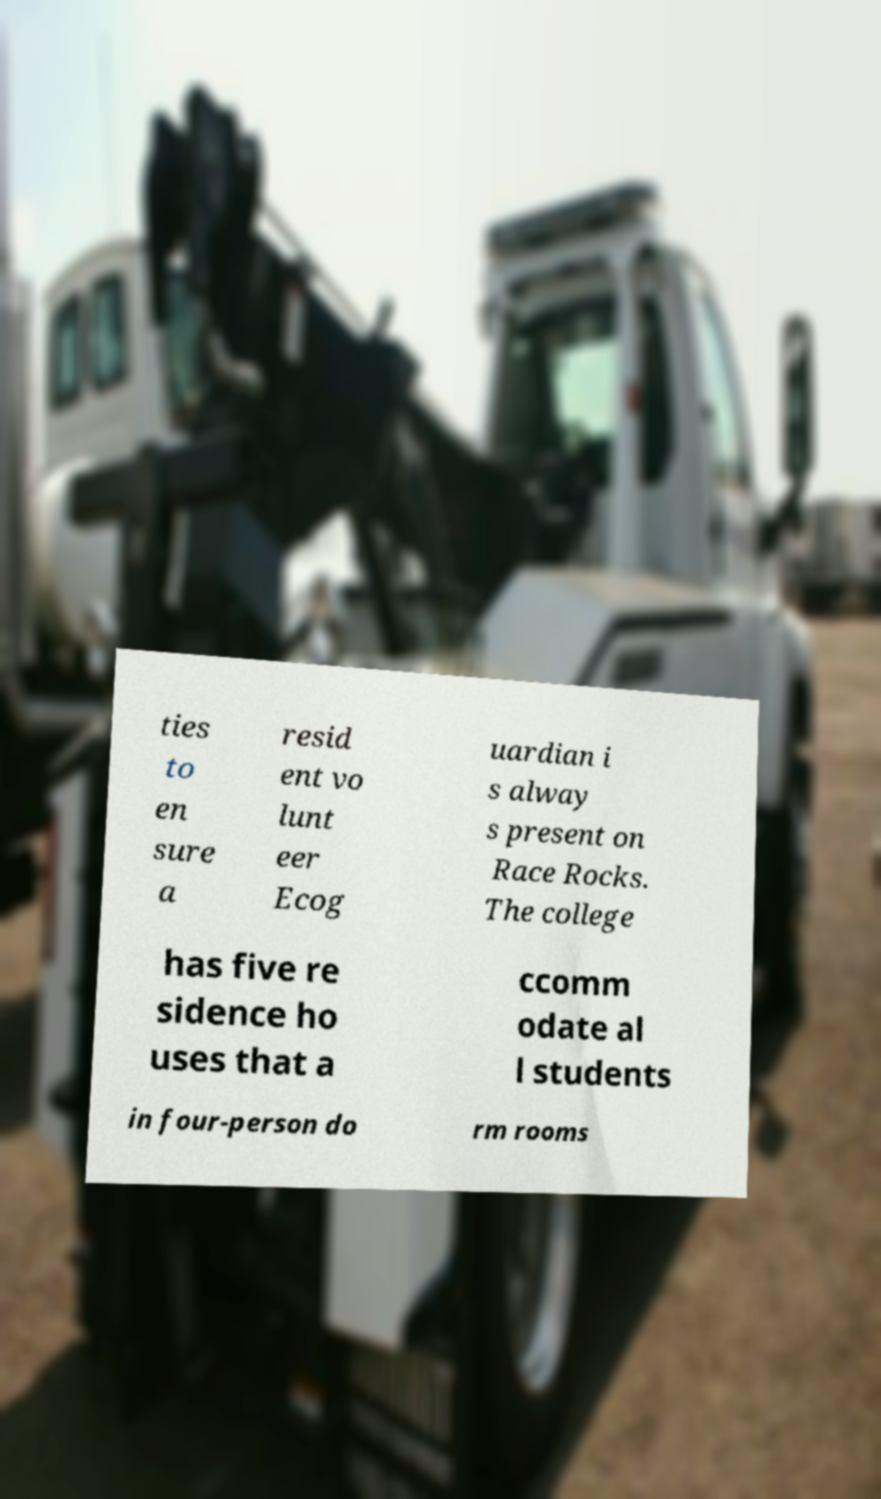I need the written content from this picture converted into text. Can you do that? ties to en sure a resid ent vo lunt eer Ecog uardian i s alway s present on Race Rocks. The college has five re sidence ho uses that a ccomm odate al l students in four-person do rm rooms 